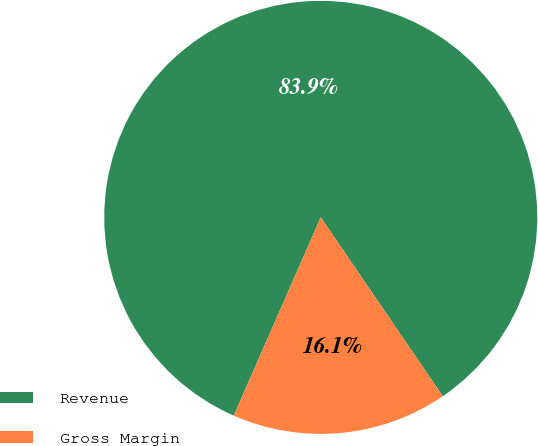Convert chart. <chart><loc_0><loc_0><loc_500><loc_500><pie_chart><fcel>Revenue<fcel>Gross Margin<nl><fcel>83.89%<fcel>16.11%<nl></chart> 